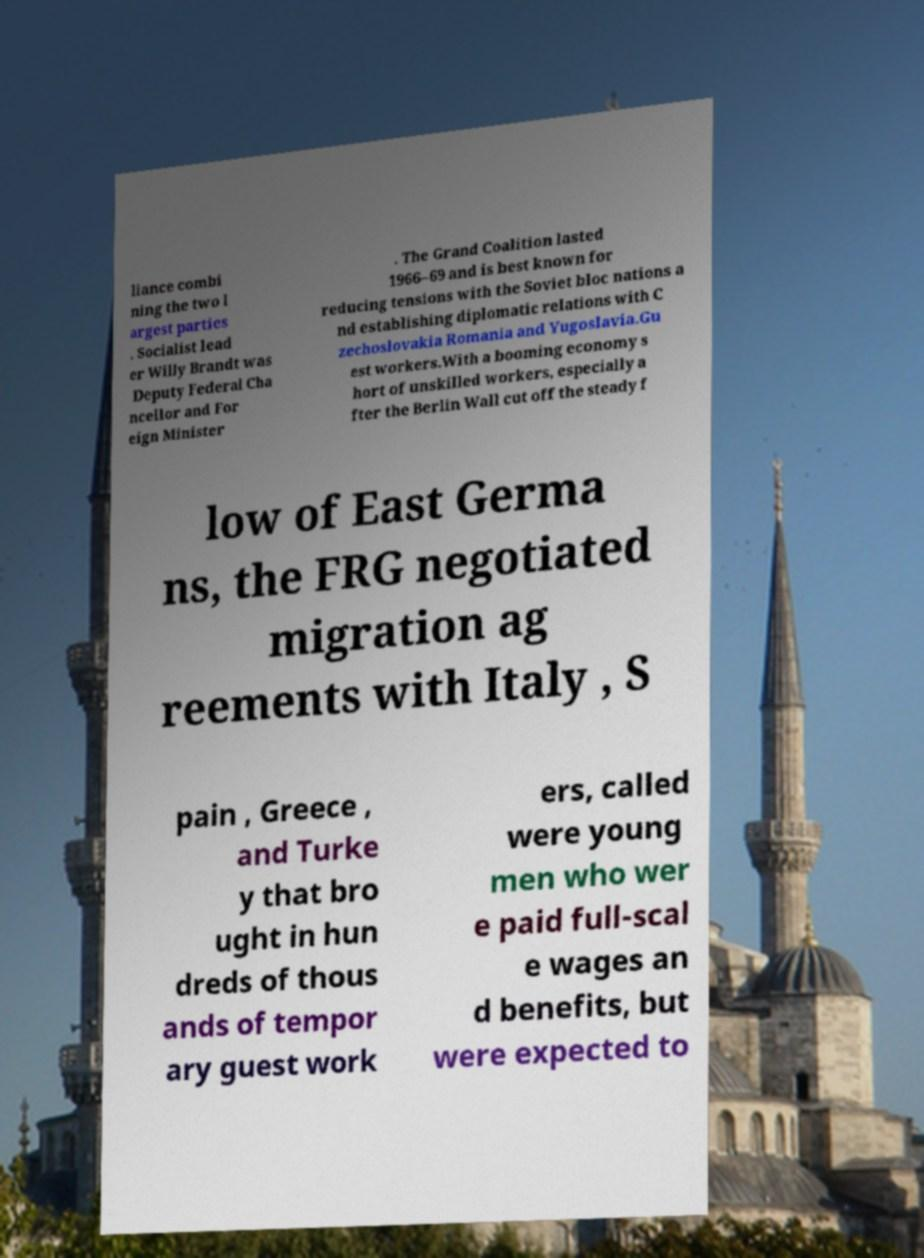What messages or text are displayed in this image? I need them in a readable, typed format. liance combi ning the two l argest parties . Socialist lead er Willy Brandt was Deputy Federal Cha ncellor and For eign Minister . The Grand Coalition lasted 1966–69 and is best known for reducing tensions with the Soviet bloc nations a nd establishing diplomatic relations with C zechoslovakia Romania and Yugoslavia.Gu est workers.With a booming economy s hort of unskilled workers, especially a fter the Berlin Wall cut off the steady f low of East Germa ns, the FRG negotiated migration ag reements with Italy , S pain , Greece , and Turke y that bro ught in hun dreds of thous ands of tempor ary guest work ers, called were young men who wer e paid full-scal e wages an d benefits, but were expected to 